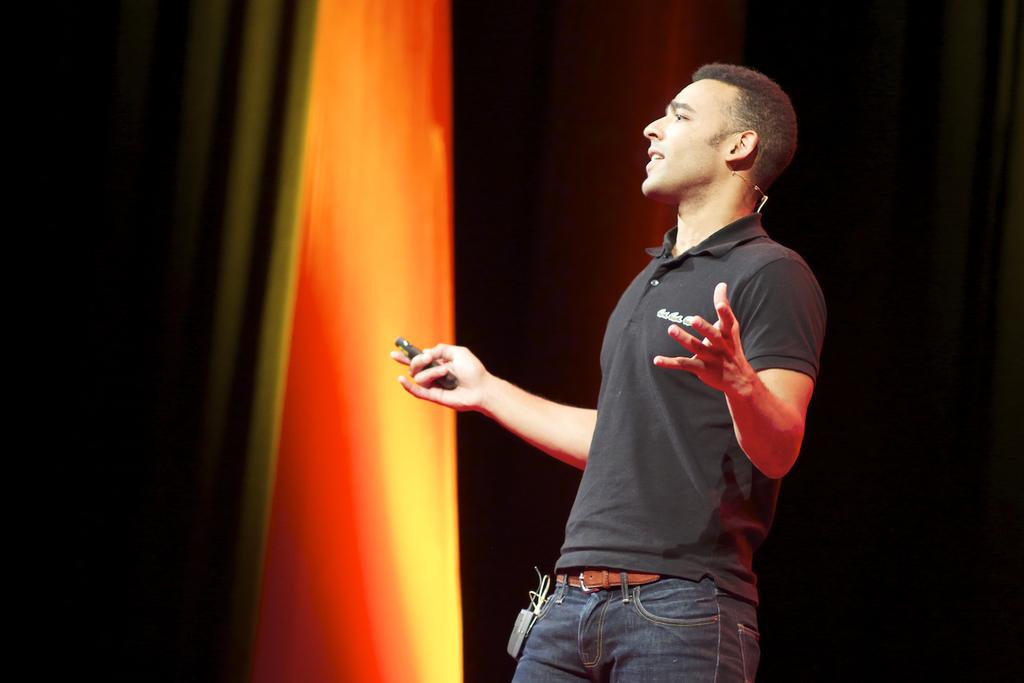What is the main subject of the picture? The main subject of the picture is a man. What is the man doing in the picture? The man is standing in the picture. What is the man holding in his hand? The man is holding an object in his hand. What color is the man's t-shirt? The man is wearing a black t-shirt. What type of pants is the man wearing? The man is wearing jeans. What type of building can be seen in the background of the image? There is no building visible in the image; it only features a man standing and holding an object. How many cattle are present in the image? There are no cattle present in the image. 